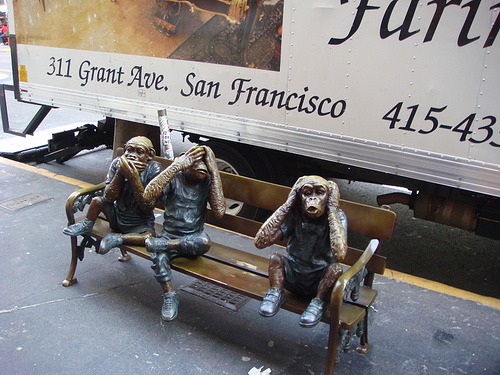<image>
Is the muffler behind the bench? Yes. From this viewpoint, the muffler is positioned behind the bench, with the bench partially or fully occluding the muffler. Where is the monkey statue in relation to the chair? Is it on the chair? Yes. Looking at the image, I can see the monkey statue is positioned on top of the chair, with the chair providing support. Where is the truck in relation to the sidewalk? Is it on the sidewalk? No. The truck is not positioned on the sidewalk. They may be near each other, but the truck is not supported by or resting on top of the sidewalk. 